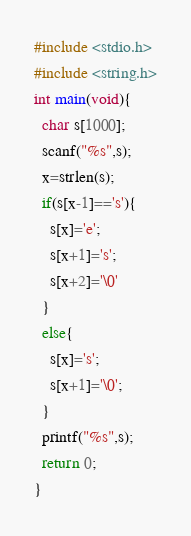<code> <loc_0><loc_0><loc_500><loc_500><_C_>#include <stdio.h>
#include <string.h>
int main(void){
  char s[1000];
  scanf("%s",s);
  x=strlen(s);
  if(s[x-1]=='s'){
    s[x]='e';
    s[x+1]='s';
    s[x+2]='\0'  
  }
  else{
    s[x]='s';
    s[x+1]='\0';
  }
  printf("%s",s);
  return 0;
}</code> 